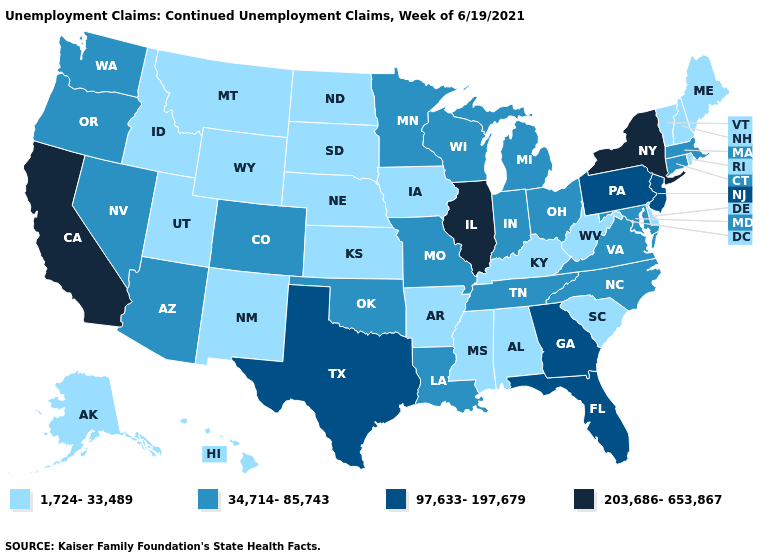What is the lowest value in the MidWest?
Write a very short answer. 1,724-33,489. How many symbols are there in the legend?
Be succinct. 4. Does the first symbol in the legend represent the smallest category?
Be succinct. Yes. Among the states that border Minnesota , which have the highest value?
Short answer required. Wisconsin. What is the value of Iowa?
Give a very brief answer. 1,724-33,489. Name the states that have a value in the range 203,686-653,867?
Concise answer only. California, Illinois, New York. How many symbols are there in the legend?
Keep it brief. 4. Does Florida have the highest value in the South?
Quick response, please. Yes. Name the states that have a value in the range 1,724-33,489?
Keep it brief. Alabama, Alaska, Arkansas, Delaware, Hawaii, Idaho, Iowa, Kansas, Kentucky, Maine, Mississippi, Montana, Nebraska, New Hampshire, New Mexico, North Dakota, Rhode Island, South Carolina, South Dakota, Utah, Vermont, West Virginia, Wyoming. Name the states that have a value in the range 34,714-85,743?
Quick response, please. Arizona, Colorado, Connecticut, Indiana, Louisiana, Maryland, Massachusetts, Michigan, Minnesota, Missouri, Nevada, North Carolina, Ohio, Oklahoma, Oregon, Tennessee, Virginia, Washington, Wisconsin. Does the first symbol in the legend represent the smallest category?
Short answer required. Yes. What is the value of Montana?
Give a very brief answer. 1,724-33,489. What is the value of Massachusetts?
Concise answer only. 34,714-85,743. Which states have the lowest value in the USA?
Give a very brief answer. Alabama, Alaska, Arkansas, Delaware, Hawaii, Idaho, Iowa, Kansas, Kentucky, Maine, Mississippi, Montana, Nebraska, New Hampshire, New Mexico, North Dakota, Rhode Island, South Carolina, South Dakota, Utah, Vermont, West Virginia, Wyoming. Which states have the highest value in the USA?
Quick response, please. California, Illinois, New York. 